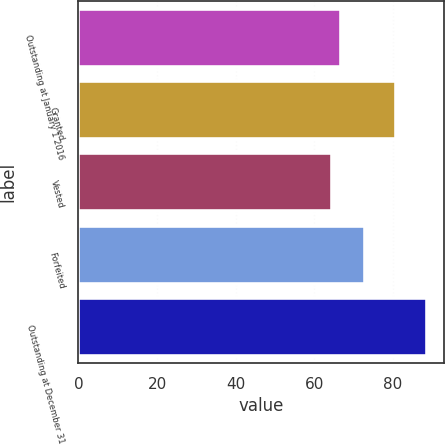Convert chart. <chart><loc_0><loc_0><loc_500><loc_500><bar_chart><fcel>Outstanding at January 1 2016<fcel>Granted<fcel>Vested<fcel>Forfeited<fcel>Outstanding at December 31<nl><fcel>66.85<fcel>80.69<fcel>64.44<fcel>72.86<fcel>88.55<nl></chart> 